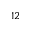Convert formula to latex. <formula><loc_0><loc_0><loc_500><loc_500>_ { 1 2 }</formula> 